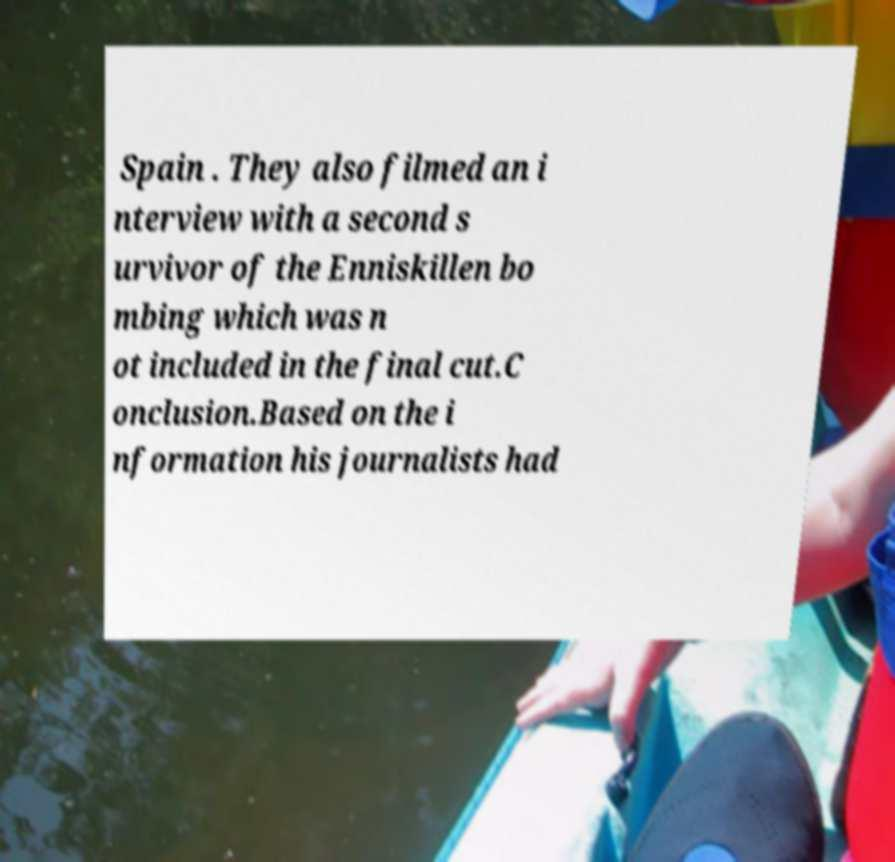Please read and relay the text visible in this image. What does it say? Spain . They also filmed an i nterview with a second s urvivor of the Enniskillen bo mbing which was n ot included in the final cut.C onclusion.Based on the i nformation his journalists had 